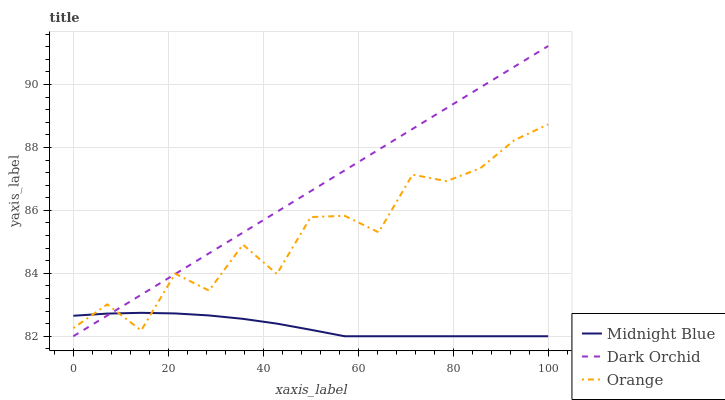Does Midnight Blue have the minimum area under the curve?
Answer yes or no. Yes. Does Dark Orchid have the maximum area under the curve?
Answer yes or no. Yes. Does Dark Orchid have the minimum area under the curve?
Answer yes or no. No. Does Midnight Blue have the maximum area under the curve?
Answer yes or no. No. Is Dark Orchid the smoothest?
Answer yes or no. Yes. Is Orange the roughest?
Answer yes or no. Yes. Is Midnight Blue the smoothest?
Answer yes or no. No. Is Midnight Blue the roughest?
Answer yes or no. No. Does Dark Orchid have the highest value?
Answer yes or no. Yes. Does Midnight Blue have the highest value?
Answer yes or no. No. Does Orange intersect Midnight Blue?
Answer yes or no. Yes. Is Orange less than Midnight Blue?
Answer yes or no. No. Is Orange greater than Midnight Blue?
Answer yes or no. No. 